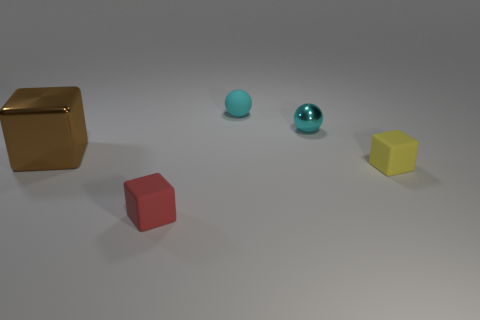Subtract all big brown blocks. How many blocks are left? 2 Subtract 1 balls. How many balls are left? 1 Add 3 large brown things. How many large brown things are left? 4 Add 3 large things. How many large things exist? 4 Add 1 tiny red cubes. How many objects exist? 6 Subtract 1 yellow cubes. How many objects are left? 4 Subtract all spheres. How many objects are left? 3 Subtract all gray spheres. Subtract all green cylinders. How many spheres are left? 2 Subtract all gray cylinders. How many brown cubes are left? 1 Subtract all tiny cyan shiny spheres. Subtract all cyan matte things. How many objects are left? 3 